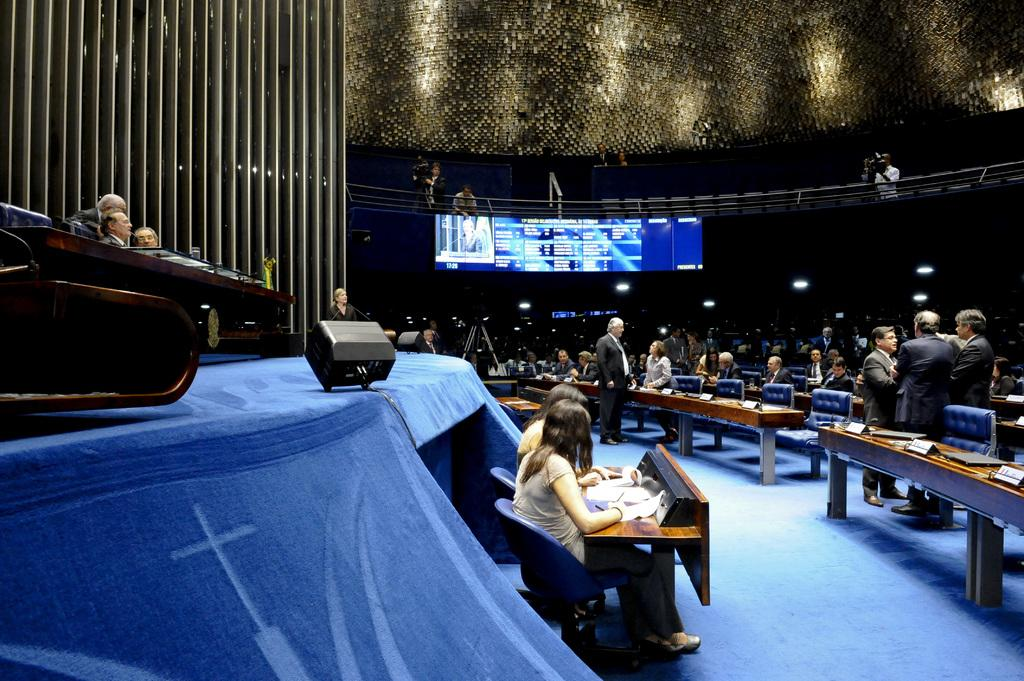What are the persons in the image doing? Some persons are sitting on chairs, while others are standing. What type of furniture is present in the image? There are chairs and a table in the image. What is on the table? There is a book and a board on the table. What can be seen in the background of the image? There is a screen visible in the background. Can you see a rabbit hopping around the table in the image? No, there is no rabbit present in the image. Is there a tramp visible in the image? No, there is no tramp present in the image. 